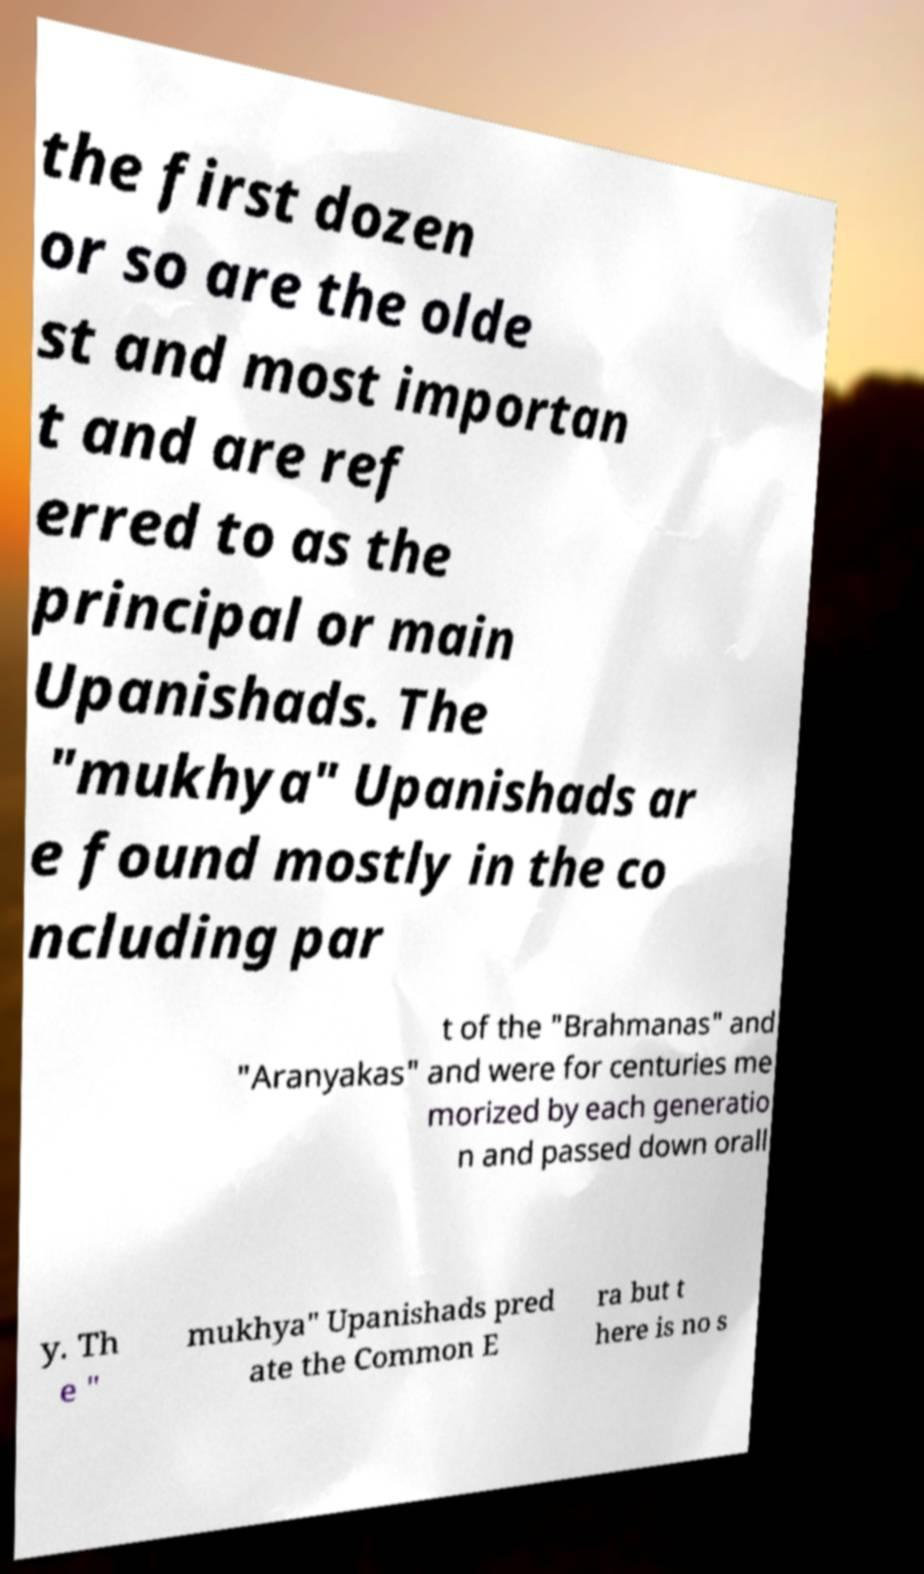Please read and relay the text visible in this image. What does it say? the first dozen or so are the olde st and most importan t and are ref erred to as the principal or main Upanishads. The "mukhya" Upanishads ar e found mostly in the co ncluding par t of the "Brahmanas" and "Aranyakas" and were for centuries me morized by each generatio n and passed down orall y. Th e " mukhya" Upanishads pred ate the Common E ra but t here is no s 